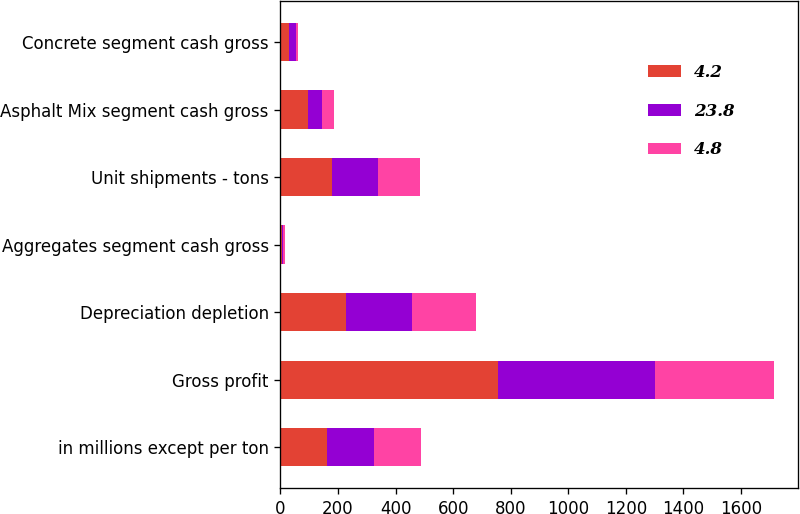Convert chart to OTSL. <chart><loc_0><loc_0><loc_500><loc_500><stacked_bar_chart><ecel><fcel>in millions except per ton<fcel>Gross profit<fcel>Depreciation depletion<fcel>Aggregates segment cash gross<fcel>Unit shipments - tons<fcel>Asphalt Mix segment cash gross<fcel>Concrete segment cash gross<nl><fcel>4.2<fcel>162.4<fcel>755.7<fcel>228.5<fcel>5.52<fcel>178.3<fcel>94.6<fcel>31.6<nl><fcel>23.8<fcel>162.4<fcel>544.1<fcel>227<fcel>4.75<fcel>162.4<fcel>48.8<fcel>22.1<nl><fcel>4.8<fcel>162.4<fcel>413.3<fcel>224.8<fcel>4.37<fcel>145.9<fcel>41.4<fcel>8.2<nl></chart> 